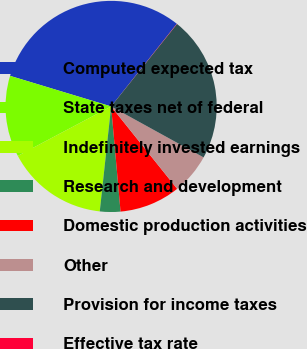Convert chart to OTSL. <chart><loc_0><loc_0><loc_500><loc_500><pie_chart><fcel>Computed expected tax<fcel>State taxes net of federal<fcel>Indefinitely invested earnings<fcel>Research and development<fcel>Domestic production activities<fcel>Other<fcel>Provision for income taxes<fcel>Effective tax rate<nl><fcel>31.01%<fcel>12.43%<fcel>15.53%<fcel>3.14%<fcel>9.33%<fcel>6.23%<fcel>22.29%<fcel>0.04%<nl></chart> 